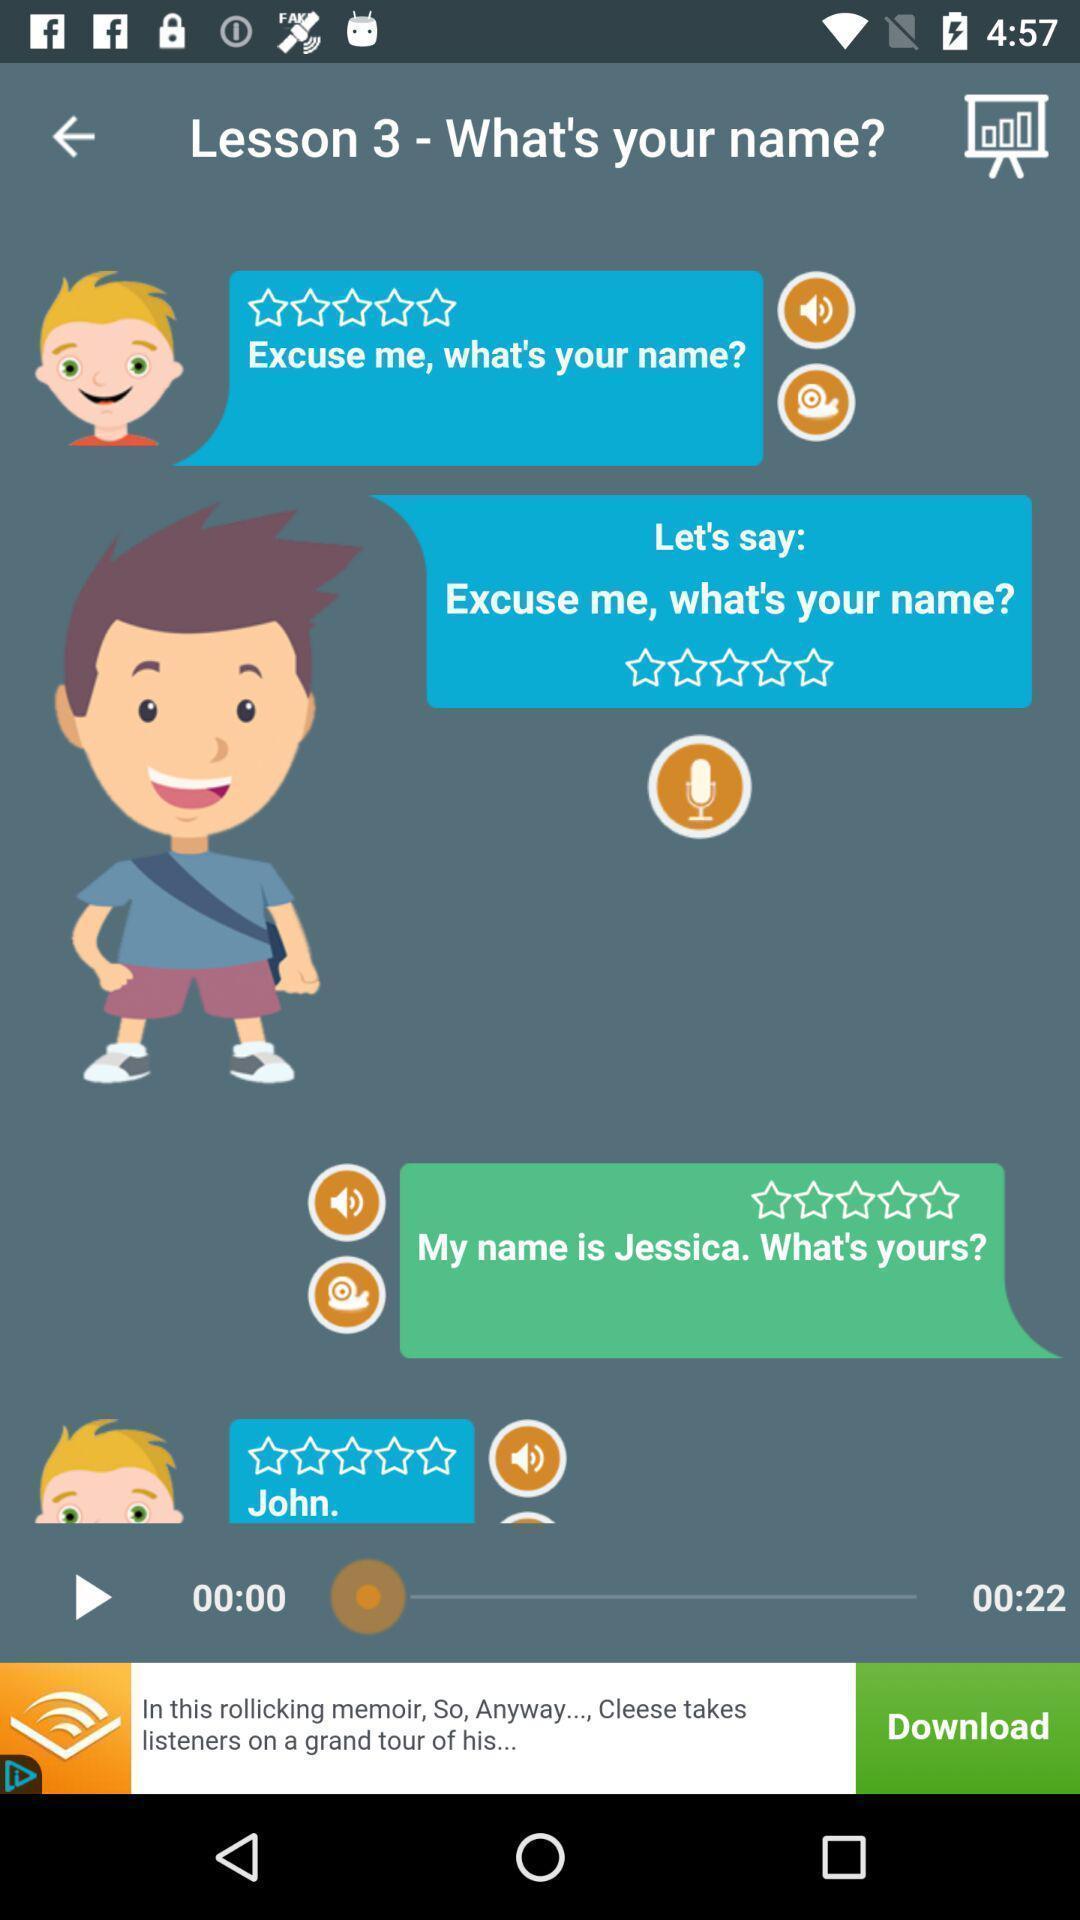What details can you identify in this image? Video paused in the lesson of the app. 